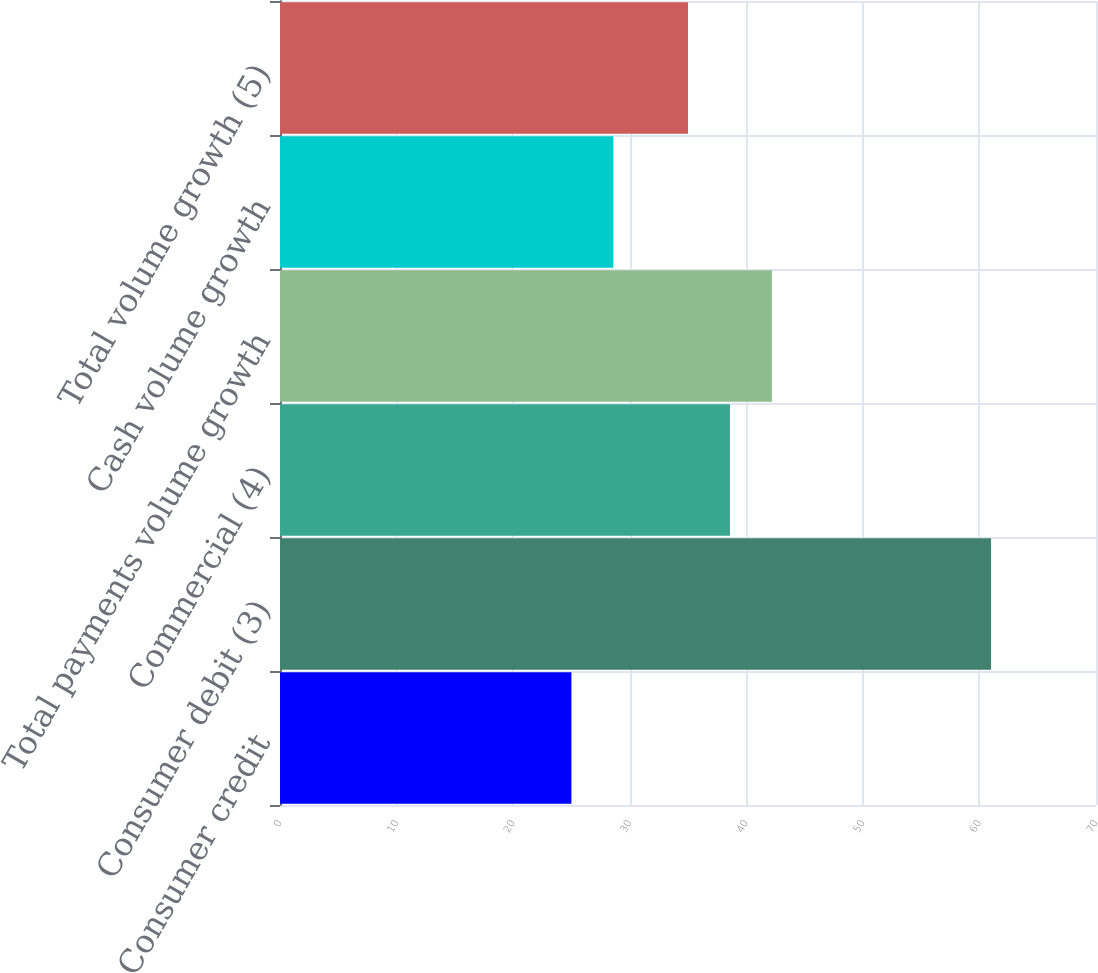<chart> <loc_0><loc_0><loc_500><loc_500><bar_chart><fcel>Consumer credit<fcel>Consumer debit (3)<fcel>Commercial (4)<fcel>Total payments volume growth<fcel>Cash volume growth<fcel>Total volume growth (5)<nl><fcel>25<fcel>61<fcel>38.6<fcel>42.2<fcel>28.6<fcel>35<nl></chart> 